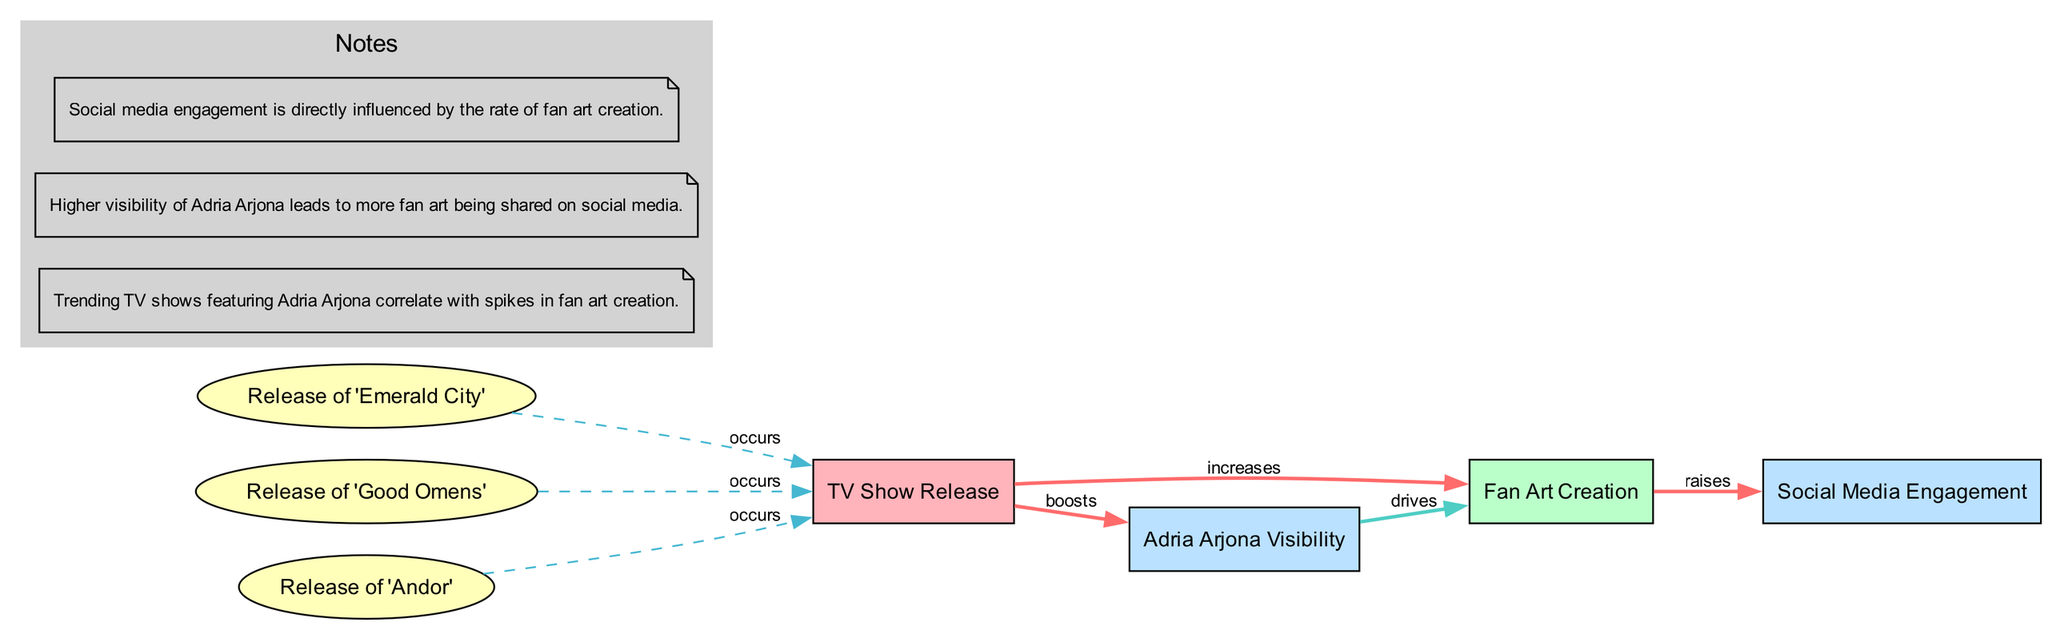What are the two primary activities represented in the diagram? The two primary activities represented in the diagram are "Fan Art Creation" and "TV Show Release." These nodes are identified in the node section, classified as activities and events, respectively.
Answer: Fan Art Creation, TV Show Release How many milestones are present in the diagram? The milestones represent significant TV show releases featuring Adria Arjona, and there are three milestones listed: "Release of 'Emerald City'," "Release of 'Good Omens'," and "Release of 'Andor'." Counting these gives us the total number of milestones.
Answer: 3 What influence does a TV show release have on fan art creation? The diagram indicates a direct influence where a TV show release "increases" fan art creation, as shown by the edge connecting these two nodes labeled "increases." This influence illustrates the relationship visually.
Answer: Increases Which metric is shown to drive fan art creation? The diagram identifies "Adria Arjona Visibility" as the metric that "drives" fan art creation, with the edge labeled "drives" indicating a causal relationship from visibility to art creation.
Answer: Adria Arjona Visibility What kind of relationship is demonstrated between social media engagement and fan art creation? The diagram shows a relationship where fan art creation "raises" social media engagement. This is represented by an edge between the two nodes labeled "raises," indicating how the activity affects the metric.
Answer: Raises Which TV show release corresponds to the first milestone in the diagram? Reviewing the milestones, the "Release of 'Emerald City'" is the first milestone shown; thus, it corresponds to the timeline associated with the first event in the diagram.
Answer: Release of 'Emerald City' What effect does higher visibility of Adria Arjona have on fan art creation? The diagram notes indicate that higher visibility of Adria Arjona leads to more fan art being shared, which is directly established by the causal edge between the visibility metric and fan art activity.
Answer: More fan art What is the overall trend suggested by the diagram regarding fan art creation and TV show releases? The diagram suggests a positive correlation between TV show releases featuring Adria Arjona and spikes in fan art creation, indicating that each release increases engagement and activity in fan art creation significantly.
Answer: Positive correlation 